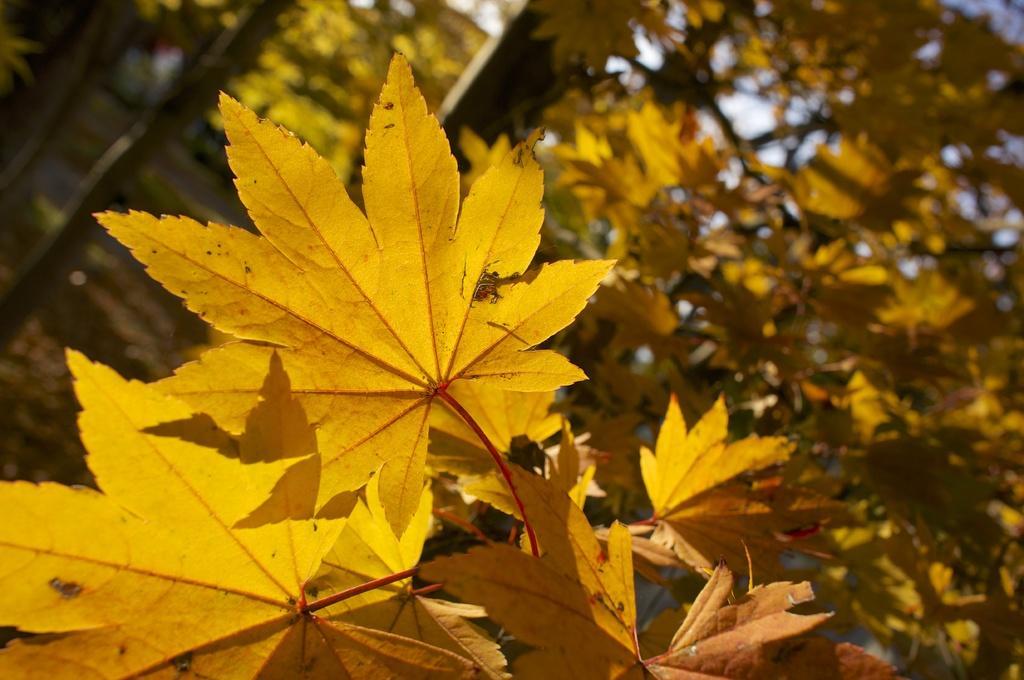Please provide a concise description of this image. In this picture I can observe leaves which are in yellow color. In the background I can observe tree and sky. 